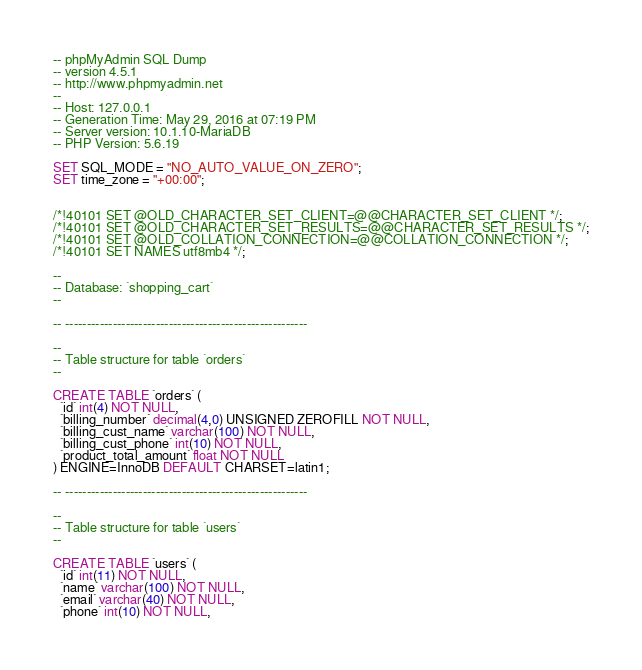<code> <loc_0><loc_0><loc_500><loc_500><_SQL_>-- phpMyAdmin SQL Dump
-- version 4.5.1
-- http://www.phpmyadmin.net
--
-- Host: 127.0.0.1
-- Generation Time: May 29, 2016 at 07:19 PM
-- Server version: 10.1.10-MariaDB
-- PHP Version: 5.6.19

SET SQL_MODE = "NO_AUTO_VALUE_ON_ZERO";
SET time_zone = "+00:00";


/*!40101 SET @OLD_CHARACTER_SET_CLIENT=@@CHARACTER_SET_CLIENT */;
/*!40101 SET @OLD_CHARACTER_SET_RESULTS=@@CHARACTER_SET_RESULTS */;
/*!40101 SET @OLD_COLLATION_CONNECTION=@@COLLATION_CONNECTION */;
/*!40101 SET NAMES utf8mb4 */;

--
-- Database: `shopping_cart`
--

-- --------------------------------------------------------

--
-- Table structure for table `orders`
--

CREATE TABLE `orders` (
  `id` int(4) NOT NULL,
  `billing_number` decimal(4,0) UNSIGNED ZEROFILL NOT NULL,
  `billing_cust_name` varchar(100) NOT NULL,
  `billing_cust_phone` int(10) NOT NULL,
  `product_total_amount` float NOT NULL
) ENGINE=InnoDB DEFAULT CHARSET=latin1;

-- --------------------------------------------------------

--
-- Table structure for table `users`
--

CREATE TABLE `users` (
  `id` int(11) NOT NULL,
  `name` varchar(100) NOT NULL,
  `email` varchar(40) NOT NULL,
  `phone` int(10) NOT NULL,</code> 